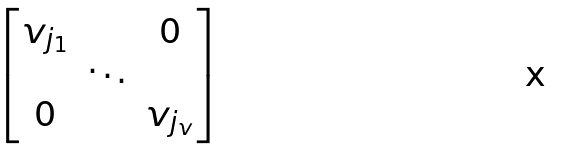<formula> <loc_0><loc_0><loc_500><loc_500>\begin{bmatrix} v _ { j _ { 1 } } & & 0 \\ & \ddots & \\ 0 & & v _ { j _ { v } } \end{bmatrix}</formula> 